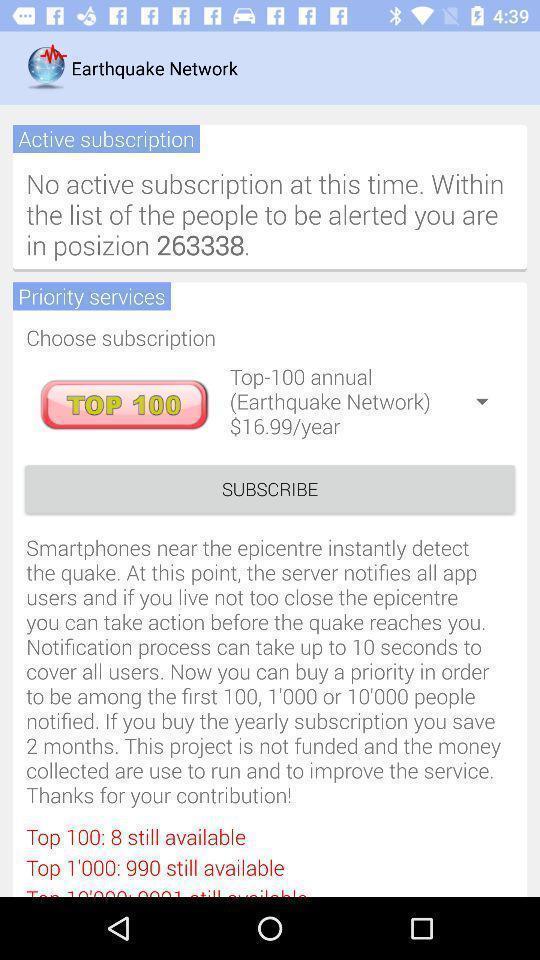Provide a textual representation of this image. Subscription status displaying in this page. 